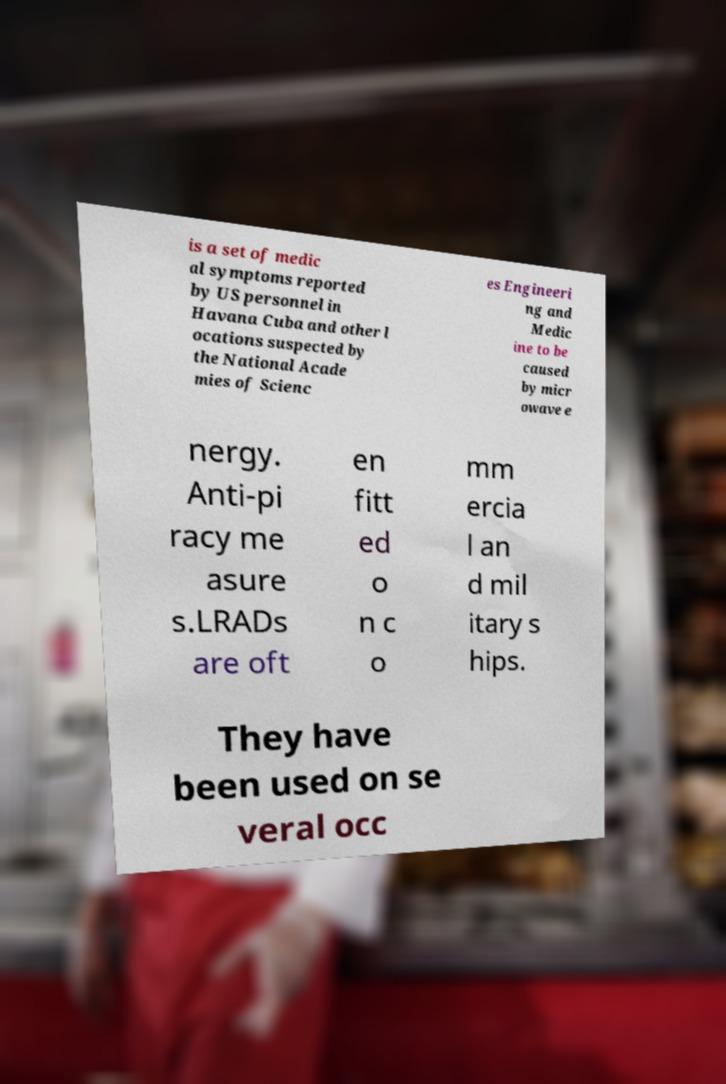Can you read and provide the text displayed in the image?This photo seems to have some interesting text. Can you extract and type it out for me? is a set of medic al symptoms reported by US personnel in Havana Cuba and other l ocations suspected by the National Acade mies of Scienc es Engineeri ng and Medic ine to be caused by micr owave e nergy. Anti-pi racy me asure s.LRADs are oft en fitt ed o n c o mm ercia l an d mil itary s hips. They have been used on se veral occ 